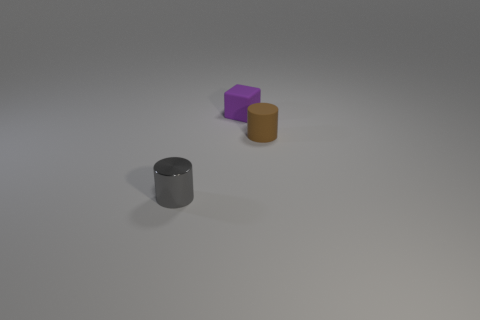Is there any other thing that is made of the same material as the small gray cylinder?
Make the answer very short. No. What is the material of the thing that is in front of the tiny purple rubber cube and behind the shiny object?
Offer a very short reply. Rubber. Is there anything else that has the same shape as the tiny purple matte object?
Offer a very short reply. No. There is a cylinder that is the same material as the purple block; what color is it?
Provide a succinct answer. Brown. How many objects are shiny cylinders or tiny cyan metallic spheres?
Provide a succinct answer. 1. Is the size of the brown cylinder the same as the gray thing on the left side of the brown matte object?
Make the answer very short. Yes. There is a tiny cylinder that is to the right of the small object that is left of the tiny rubber object behind the brown matte object; what color is it?
Give a very brief answer. Brown. The small shiny object has what color?
Provide a succinct answer. Gray. Are there more purple things that are right of the brown matte thing than small gray metallic cylinders that are in front of the tiny gray metal cylinder?
Your response must be concise. No. Do the small metal thing and the tiny matte thing on the left side of the brown cylinder have the same shape?
Offer a very short reply. No. 